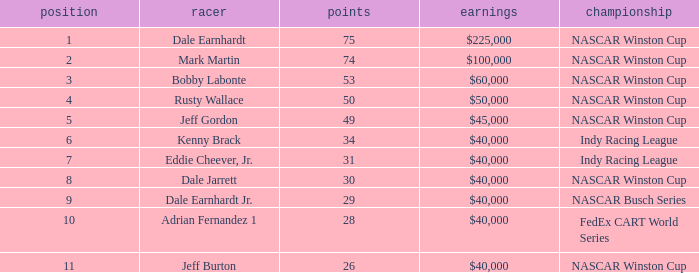In what position was the driver who won $60,000? 3.0. 